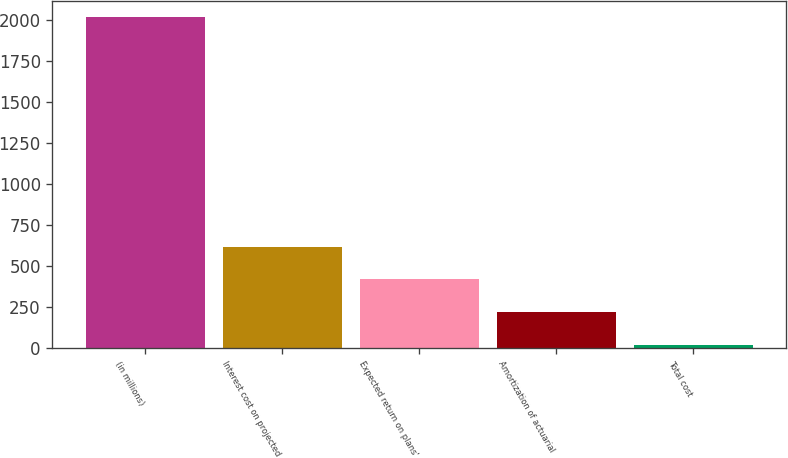<chart> <loc_0><loc_0><loc_500><loc_500><bar_chart><fcel>(in millions)<fcel>Interest cost on projected<fcel>Expected return on plans'<fcel>Amortization of actuarial<fcel>Total cost<nl><fcel>2015<fcel>619.2<fcel>419.8<fcel>220.4<fcel>21<nl></chart> 